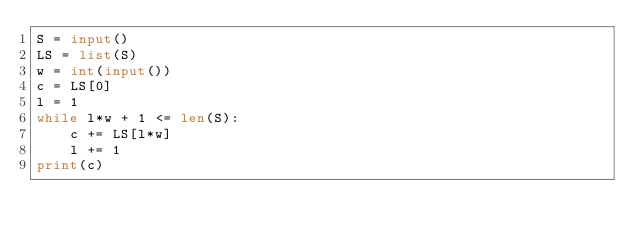Convert code to text. <code><loc_0><loc_0><loc_500><loc_500><_Python_>S = input()
LS = list(S)
w = int(input())
c = LS[0]
l = 1
while l*w + 1 <= len(S):
    c += LS[l*w]
    l += 1
print(c)</code> 